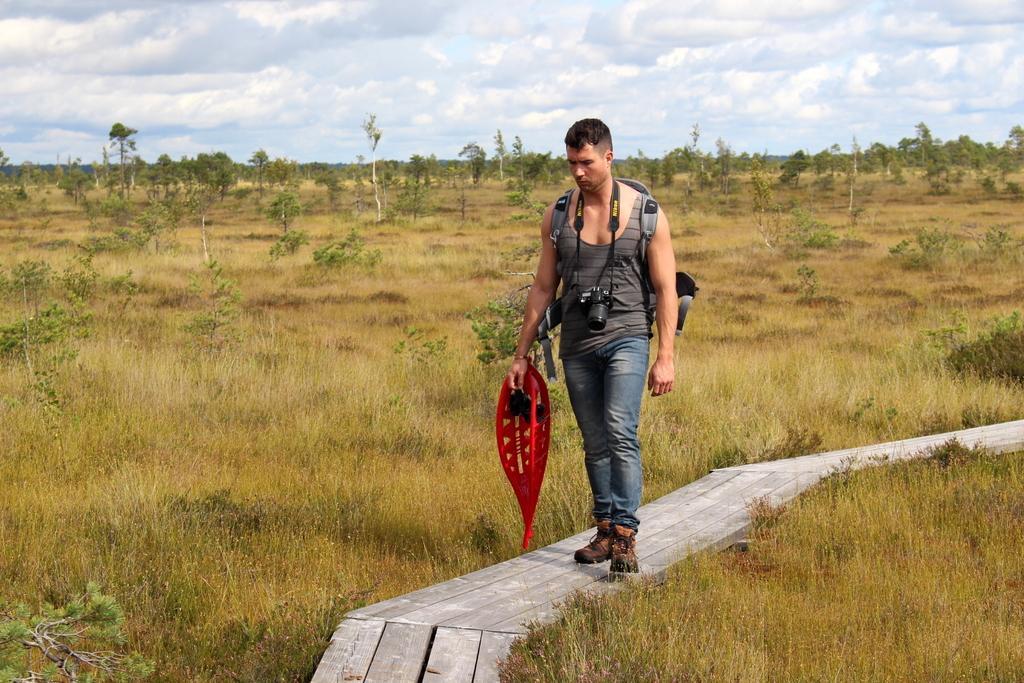Can you describe this image briefly? In this image we can see a person holding an object and wearing a backpack and a camera, there are some plants, grass and trees, in the background we can see the sky with clouds. 